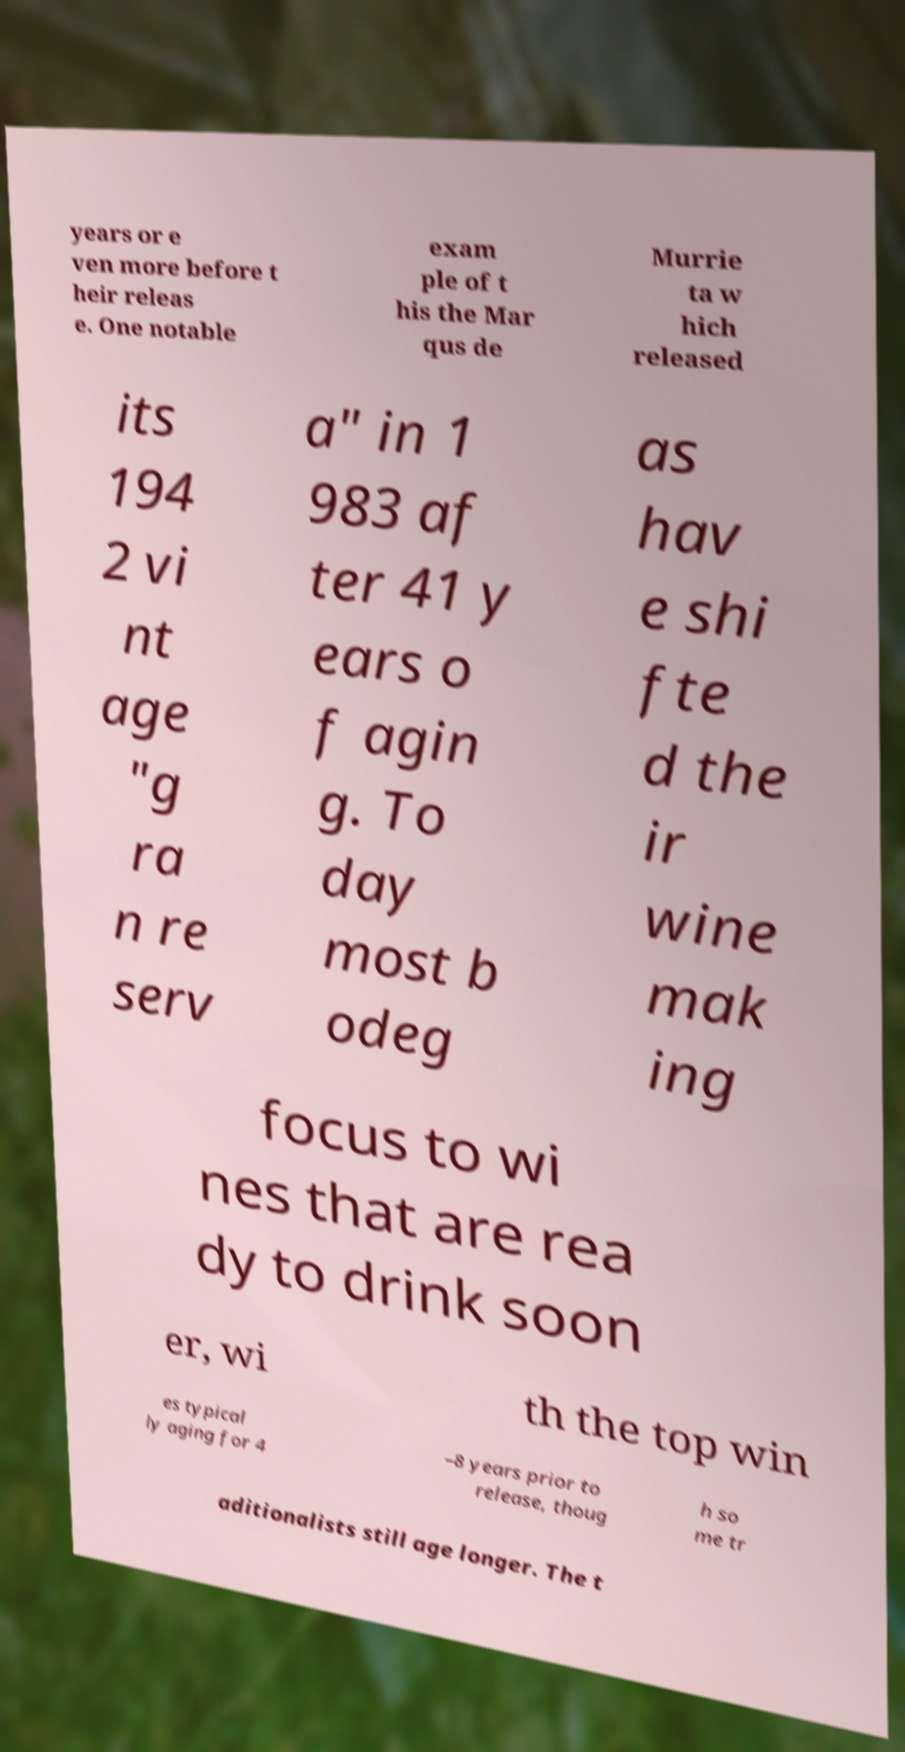Can you read and provide the text displayed in the image?This photo seems to have some interesting text. Can you extract and type it out for me? years or e ven more before t heir releas e. One notable exam ple of t his the Mar qus de Murrie ta w hich released its 194 2 vi nt age "g ra n re serv a" in 1 983 af ter 41 y ears o f agin g. To day most b odeg as hav e shi fte d the ir wine mak ing focus to wi nes that are rea dy to drink soon er, wi th the top win es typical ly aging for 4 –8 years prior to release, thoug h so me tr aditionalists still age longer. The t 